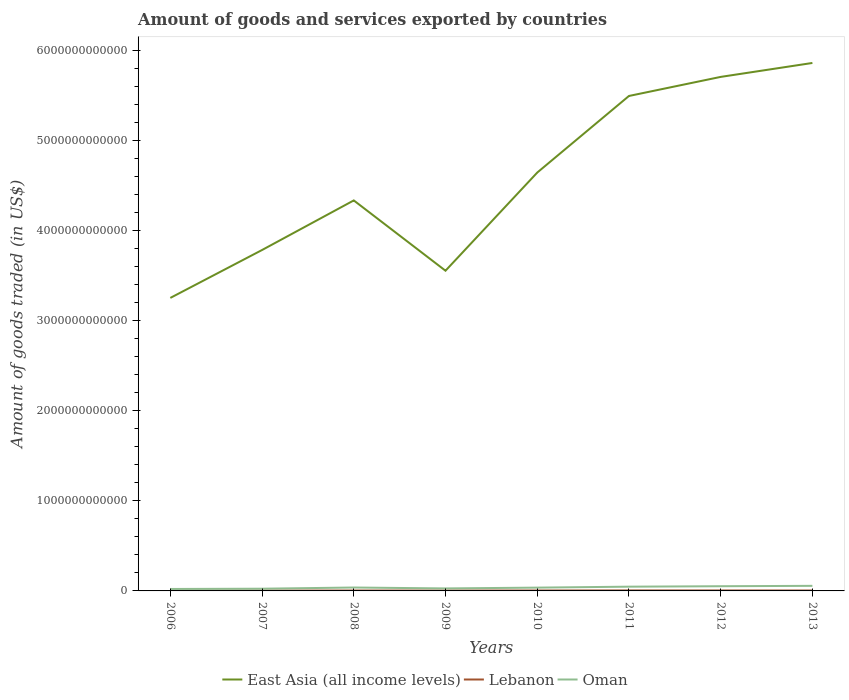How many different coloured lines are there?
Provide a succinct answer. 3. Does the line corresponding to Oman intersect with the line corresponding to Lebanon?
Keep it short and to the point. No. Across all years, what is the maximum total amount of goods and services exported in East Asia (all income levels)?
Provide a short and direct response. 3.25e+12. In which year was the total amount of goods and services exported in Oman maximum?
Provide a short and direct response. 2006. What is the total total amount of goods and services exported in Oman in the graph?
Ensure brevity in your answer.  -4.29e+09. What is the difference between the highest and the second highest total amount of goods and services exported in Oman?
Your response must be concise. 3.48e+1. What is the difference between the highest and the lowest total amount of goods and services exported in Lebanon?
Ensure brevity in your answer.  5. Is the total amount of goods and services exported in Oman strictly greater than the total amount of goods and services exported in Lebanon over the years?
Give a very brief answer. No. How many years are there in the graph?
Provide a succinct answer. 8. What is the difference between two consecutive major ticks on the Y-axis?
Provide a succinct answer. 1.00e+12. Are the values on the major ticks of Y-axis written in scientific E-notation?
Your response must be concise. No. Where does the legend appear in the graph?
Your response must be concise. Bottom center. How are the legend labels stacked?
Your response must be concise. Horizontal. What is the title of the graph?
Make the answer very short. Amount of goods and services exported by countries. Does "Bulgaria" appear as one of the legend labels in the graph?
Offer a very short reply. No. What is the label or title of the Y-axis?
Your answer should be compact. Amount of goods traded (in US$). What is the Amount of goods traded (in US$) of East Asia (all income levels) in 2006?
Make the answer very short. 3.25e+12. What is the Amount of goods traded (in US$) in Lebanon in 2006?
Give a very brief answer. 2.81e+09. What is the Amount of goods traded (in US$) of Oman in 2006?
Your response must be concise. 2.16e+1. What is the Amount of goods traded (in US$) in East Asia (all income levels) in 2007?
Keep it short and to the point. 3.78e+12. What is the Amount of goods traded (in US$) of Lebanon in 2007?
Give a very brief answer. 3.57e+09. What is the Amount of goods traded (in US$) of Oman in 2007?
Offer a very short reply. 2.47e+1. What is the Amount of goods traded (in US$) in East Asia (all income levels) in 2008?
Offer a terse response. 4.33e+12. What is the Amount of goods traded (in US$) in Lebanon in 2008?
Make the answer very short. 4.45e+09. What is the Amount of goods traded (in US$) of Oman in 2008?
Offer a very short reply. 3.77e+1. What is the Amount of goods traded (in US$) in East Asia (all income levels) in 2009?
Ensure brevity in your answer.  3.55e+12. What is the Amount of goods traded (in US$) of Lebanon in 2009?
Your answer should be very brief. 4.19e+09. What is the Amount of goods traded (in US$) of Oman in 2009?
Your answer should be very brief. 2.77e+1. What is the Amount of goods traded (in US$) in East Asia (all income levels) in 2010?
Offer a very short reply. 4.64e+12. What is the Amount of goods traded (in US$) of Lebanon in 2010?
Your response must be concise. 4.69e+09. What is the Amount of goods traded (in US$) of Oman in 2010?
Your answer should be very brief. 3.66e+1. What is the Amount of goods traded (in US$) in East Asia (all income levels) in 2011?
Your answer should be compact. 5.49e+12. What is the Amount of goods traded (in US$) in Lebanon in 2011?
Offer a very short reply. 5.39e+09. What is the Amount of goods traded (in US$) of Oman in 2011?
Your answer should be very brief. 4.71e+1. What is the Amount of goods traded (in US$) of East Asia (all income levels) in 2012?
Make the answer very short. 5.70e+12. What is the Amount of goods traded (in US$) of Lebanon in 2012?
Provide a short and direct response. 5.01e+09. What is the Amount of goods traded (in US$) of Oman in 2012?
Provide a short and direct response. 5.21e+1. What is the Amount of goods traded (in US$) of East Asia (all income levels) in 2013?
Provide a succinct answer. 5.86e+12. What is the Amount of goods traded (in US$) in Lebanon in 2013?
Make the answer very short. 4.50e+09. What is the Amount of goods traded (in US$) of Oman in 2013?
Your response must be concise. 5.64e+1. Across all years, what is the maximum Amount of goods traded (in US$) in East Asia (all income levels)?
Give a very brief answer. 5.86e+12. Across all years, what is the maximum Amount of goods traded (in US$) of Lebanon?
Offer a very short reply. 5.39e+09. Across all years, what is the maximum Amount of goods traded (in US$) of Oman?
Keep it short and to the point. 5.64e+1. Across all years, what is the minimum Amount of goods traded (in US$) of East Asia (all income levels)?
Keep it short and to the point. 3.25e+12. Across all years, what is the minimum Amount of goods traded (in US$) in Lebanon?
Ensure brevity in your answer.  2.81e+09. Across all years, what is the minimum Amount of goods traded (in US$) of Oman?
Offer a terse response. 2.16e+1. What is the total Amount of goods traded (in US$) of East Asia (all income levels) in the graph?
Offer a very short reply. 3.66e+13. What is the total Amount of goods traded (in US$) of Lebanon in the graph?
Your response must be concise. 3.46e+1. What is the total Amount of goods traded (in US$) of Oman in the graph?
Your response must be concise. 3.04e+11. What is the difference between the Amount of goods traded (in US$) of East Asia (all income levels) in 2006 and that in 2007?
Your response must be concise. -5.32e+11. What is the difference between the Amount of goods traded (in US$) of Lebanon in 2006 and that in 2007?
Provide a short and direct response. -7.60e+08. What is the difference between the Amount of goods traded (in US$) in Oman in 2006 and that in 2007?
Ensure brevity in your answer.  -3.11e+09. What is the difference between the Amount of goods traded (in US$) in East Asia (all income levels) in 2006 and that in 2008?
Keep it short and to the point. -1.08e+12. What is the difference between the Amount of goods traded (in US$) in Lebanon in 2006 and that in 2008?
Your response must be concise. -1.64e+09. What is the difference between the Amount of goods traded (in US$) in Oman in 2006 and that in 2008?
Give a very brief answer. -1.61e+1. What is the difference between the Amount of goods traded (in US$) in East Asia (all income levels) in 2006 and that in 2009?
Give a very brief answer. -3.02e+11. What is the difference between the Amount of goods traded (in US$) of Lebanon in 2006 and that in 2009?
Your answer should be very brief. -1.37e+09. What is the difference between the Amount of goods traded (in US$) of Oman in 2006 and that in 2009?
Make the answer very short. -6.07e+09. What is the difference between the Amount of goods traded (in US$) in East Asia (all income levels) in 2006 and that in 2010?
Give a very brief answer. -1.39e+12. What is the difference between the Amount of goods traded (in US$) in Lebanon in 2006 and that in 2010?
Keep it short and to the point. -1.87e+09. What is the difference between the Amount of goods traded (in US$) of Oman in 2006 and that in 2010?
Your answer should be very brief. -1.50e+1. What is the difference between the Amount of goods traded (in US$) of East Asia (all income levels) in 2006 and that in 2011?
Provide a short and direct response. -2.24e+12. What is the difference between the Amount of goods traded (in US$) of Lebanon in 2006 and that in 2011?
Offer a very short reply. -2.57e+09. What is the difference between the Amount of goods traded (in US$) in Oman in 2006 and that in 2011?
Ensure brevity in your answer.  -2.55e+1. What is the difference between the Amount of goods traded (in US$) of East Asia (all income levels) in 2006 and that in 2012?
Make the answer very short. -2.45e+12. What is the difference between the Amount of goods traded (in US$) of Lebanon in 2006 and that in 2012?
Keep it short and to the point. -2.19e+09. What is the difference between the Amount of goods traded (in US$) of Oman in 2006 and that in 2012?
Your answer should be compact. -3.06e+1. What is the difference between the Amount of goods traded (in US$) in East Asia (all income levels) in 2006 and that in 2013?
Make the answer very short. -2.61e+12. What is the difference between the Amount of goods traded (in US$) in Lebanon in 2006 and that in 2013?
Your answer should be very brief. -1.68e+09. What is the difference between the Amount of goods traded (in US$) in Oman in 2006 and that in 2013?
Provide a succinct answer. -3.48e+1. What is the difference between the Amount of goods traded (in US$) of East Asia (all income levels) in 2007 and that in 2008?
Give a very brief answer. -5.50e+11. What is the difference between the Amount of goods traded (in US$) of Lebanon in 2007 and that in 2008?
Offer a very short reply. -8.79e+08. What is the difference between the Amount of goods traded (in US$) in Oman in 2007 and that in 2008?
Give a very brief answer. -1.30e+1. What is the difference between the Amount of goods traded (in US$) of East Asia (all income levels) in 2007 and that in 2009?
Offer a very short reply. 2.30e+11. What is the difference between the Amount of goods traded (in US$) in Lebanon in 2007 and that in 2009?
Keep it short and to the point. -6.13e+08. What is the difference between the Amount of goods traded (in US$) in Oman in 2007 and that in 2009?
Your answer should be compact. -2.96e+09. What is the difference between the Amount of goods traded (in US$) in East Asia (all income levels) in 2007 and that in 2010?
Offer a very short reply. -8.59e+11. What is the difference between the Amount of goods traded (in US$) in Lebanon in 2007 and that in 2010?
Provide a succinct answer. -1.11e+09. What is the difference between the Amount of goods traded (in US$) of Oman in 2007 and that in 2010?
Ensure brevity in your answer.  -1.19e+1. What is the difference between the Amount of goods traded (in US$) of East Asia (all income levels) in 2007 and that in 2011?
Provide a short and direct response. -1.71e+12. What is the difference between the Amount of goods traded (in US$) of Lebanon in 2007 and that in 2011?
Make the answer very short. -1.81e+09. What is the difference between the Amount of goods traded (in US$) in Oman in 2007 and that in 2011?
Make the answer very short. -2.24e+1. What is the difference between the Amount of goods traded (in US$) of East Asia (all income levels) in 2007 and that in 2012?
Make the answer very short. -1.92e+12. What is the difference between the Amount of goods traded (in US$) of Lebanon in 2007 and that in 2012?
Provide a short and direct response. -1.43e+09. What is the difference between the Amount of goods traded (in US$) of Oman in 2007 and that in 2012?
Provide a succinct answer. -2.74e+1. What is the difference between the Amount of goods traded (in US$) in East Asia (all income levels) in 2007 and that in 2013?
Your answer should be compact. -2.08e+12. What is the difference between the Amount of goods traded (in US$) of Lebanon in 2007 and that in 2013?
Keep it short and to the point. -9.24e+08. What is the difference between the Amount of goods traded (in US$) of Oman in 2007 and that in 2013?
Keep it short and to the point. -3.17e+1. What is the difference between the Amount of goods traded (in US$) in East Asia (all income levels) in 2008 and that in 2009?
Your answer should be compact. 7.80e+11. What is the difference between the Amount of goods traded (in US$) in Lebanon in 2008 and that in 2009?
Offer a very short reply. 2.67e+08. What is the difference between the Amount of goods traded (in US$) of Oman in 2008 and that in 2009?
Your response must be concise. 1.01e+1. What is the difference between the Amount of goods traded (in US$) in East Asia (all income levels) in 2008 and that in 2010?
Make the answer very short. -3.09e+11. What is the difference between the Amount of goods traded (in US$) of Lebanon in 2008 and that in 2010?
Your answer should be very brief. -2.35e+08. What is the difference between the Amount of goods traded (in US$) of Oman in 2008 and that in 2010?
Provide a short and direct response. 1.12e+09. What is the difference between the Amount of goods traded (in US$) of East Asia (all income levels) in 2008 and that in 2011?
Give a very brief answer. -1.16e+12. What is the difference between the Amount of goods traded (in US$) of Lebanon in 2008 and that in 2011?
Your answer should be compact. -9.32e+08. What is the difference between the Amount of goods traded (in US$) in Oman in 2008 and that in 2011?
Give a very brief answer. -9.37e+09. What is the difference between the Amount of goods traded (in US$) in East Asia (all income levels) in 2008 and that in 2012?
Provide a short and direct response. -1.37e+12. What is the difference between the Amount of goods traded (in US$) in Lebanon in 2008 and that in 2012?
Keep it short and to the point. -5.55e+08. What is the difference between the Amount of goods traded (in US$) of Oman in 2008 and that in 2012?
Provide a short and direct response. -1.44e+1. What is the difference between the Amount of goods traded (in US$) of East Asia (all income levels) in 2008 and that in 2013?
Offer a very short reply. -1.53e+12. What is the difference between the Amount of goods traded (in US$) in Lebanon in 2008 and that in 2013?
Ensure brevity in your answer.  -4.51e+07. What is the difference between the Amount of goods traded (in US$) of Oman in 2008 and that in 2013?
Provide a short and direct response. -1.87e+1. What is the difference between the Amount of goods traded (in US$) in East Asia (all income levels) in 2009 and that in 2010?
Make the answer very short. -1.09e+12. What is the difference between the Amount of goods traded (in US$) in Lebanon in 2009 and that in 2010?
Provide a succinct answer. -5.02e+08. What is the difference between the Amount of goods traded (in US$) of Oman in 2009 and that in 2010?
Offer a terse response. -8.95e+09. What is the difference between the Amount of goods traded (in US$) of East Asia (all income levels) in 2009 and that in 2011?
Your answer should be compact. -1.94e+12. What is the difference between the Amount of goods traded (in US$) in Lebanon in 2009 and that in 2011?
Offer a terse response. -1.20e+09. What is the difference between the Amount of goods traded (in US$) in Oman in 2009 and that in 2011?
Your response must be concise. -1.94e+1. What is the difference between the Amount of goods traded (in US$) of East Asia (all income levels) in 2009 and that in 2012?
Make the answer very short. -2.15e+12. What is the difference between the Amount of goods traded (in US$) of Lebanon in 2009 and that in 2012?
Make the answer very short. -8.21e+08. What is the difference between the Amount of goods traded (in US$) in Oman in 2009 and that in 2012?
Your answer should be very brief. -2.45e+1. What is the difference between the Amount of goods traded (in US$) in East Asia (all income levels) in 2009 and that in 2013?
Provide a succinct answer. -2.31e+12. What is the difference between the Amount of goods traded (in US$) of Lebanon in 2009 and that in 2013?
Offer a very short reply. -3.12e+08. What is the difference between the Amount of goods traded (in US$) in Oman in 2009 and that in 2013?
Ensure brevity in your answer.  -2.88e+1. What is the difference between the Amount of goods traded (in US$) in East Asia (all income levels) in 2010 and that in 2011?
Your answer should be very brief. -8.50e+11. What is the difference between the Amount of goods traded (in US$) of Lebanon in 2010 and that in 2011?
Keep it short and to the point. -6.97e+08. What is the difference between the Amount of goods traded (in US$) in Oman in 2010 and that in 2011?
Offer a terse response. -1.05e+1. What is the difference between the Amount of goods traded (in US$) in East Asia (all income levels) in 2010 and that in 2012?
Your response must be concise. -1.06e+12. What is the difference between the Amount of goods traded (in US$) in Lebanon in 2010 and that in 2012?
Your answer should be very brief. -3.20e+08. What is the difference between the Amount of goods traded (in US$) of Oman in 2010 and that in 2012?
Your response must be concise. -1.55e+1. What is the difference between the Amount of goods traded (in US$) in East Asia (all income levels) in 2010 and that in 2013?
Ensure brevity in your answer.  -1.22e+12. What is the difference between the Amount of goods traded (in US$) of Lebanon in 2010 and that in 2013?
Your response must be concise. 1.90e+08. What is the difference between the Amount of goods traded (in US$) of Oman in 2010 and that in 2013?
Give a very brief answer. -1.98e+1. What is the difference between the Amount of goods traded (in US$) of East Asia (all income levels) in 2011 and that in 2012?
Provide a short and direct response. -2.12e+11. What is the difference between the Amount of goods traded (in US$) of Lebanon in 2011 and that in 2012?
Offer a very short reply. 3.77e+08. What is the difference between the Amount of goods traded (in US$) in Oman in 2011 and that in 2012?
Your answer should be very brief. -5.05e+09. What is the difference between the Amount of goods traded (in US$) in East Asia (all income levels) in 2011 and that in 2013?
Make the answer very short. -3.66e+11. What is the difference between the Amount of goods traded (in US$) of Lebanon in 2011 and that in 2013?
Offer a very short reply. 8.87e+08. What is the difference between the Amount of goods traded (in US$) of Oman in 2011 and that in 2013?
Your answer should be compact. -9.34e+09. What is the difference between the Amount of goods traded (in US$) of East Asia (all income levels) in 2012 and that in 2013?
Your answer should be very brief. -1.55e+11. What is the difference between the Amount of goods traded (in US$) in Lebanon in 2012 and that in 2013?
Offer a terse response. 5.10e+08. What is the difference between the Amount of goods traded (in US$) in Oman in 2012 and that in 2013?
Provide a short and direct response. -4.29e+09. What is the difference between the Amount of goods traded (in US$) of East Asia (all income levels) in 2006 and the Amount of goods traded (in US$) of Lebanon in 2007?
Make the answer very short. 3.25e+12. What is the difference between the Amount of goods traded (in US$) of East Asia (all income levels) in 2006 and the Amount of goods traded (in US$) of Oman in 2007?
Provide a succinct answer. 3.23e+12. What is the difference between the Amount of goods traded (in US$) in Lebanon in 2006 and the Amount of goods traded (in US$) in Oman in 2007?
Offer a terse response. -2.19e+1. What is the difference between the Amount of goods traded (in US$) in East Asia (all income levels) in 2006 and the Amount of goods traded (in US$) in Lebanon in 2008?
Provide a succinct answer. 3.25e+12. What is the difference between the Amount of goods traded (in US$) of East Asia (all income levels) in 2006 and the Amount of goods traded (in US$) of Oman in 2008?
Make the answer very short. 3.21e+12. What is the difference between the Amount of goods traded (in US$) in Lebanon in 2006 and the Amount of goods traded (in US$) in Oman in 2008?
Offer a very short reply. -3.49e+1. What is the difference between the Amount of goods traded (in US$) in East Asia (all income levels) in 2006 and the Amount of goods traded (in US$) in Lebanon in 2009?
Make the answer very short. 3.25e+12. What is the difference between the Amount of goods traded (in US$) of East Asia (all income levels) in 2006 and the Amount of goods traded (in US$) of Oman in 2009?
Give a very brief answer. 3.22e+12. What is the difference between the Amount of goods traded (in US$) in Lebanon in 2006 and the Amount of goods traded (in US$) in Oman in 2009?
Your answer should be very brief. -2.48e+1. What is the difference between the Amount of goods traded (in US$) in East Asia (all income levels) in 2006 and the Amount of goods traded (in US$) in Lebanon in 2010?
Your answer should be compact. 3.25e+12. What is the difference between the Amount of goods traded (in US$) in East Asia (all income levels) in 2006 and the Amount of goods traded (in US$) in Oman in 2010?
Provide a succinct answer. 3.22e+12. What is the difference between the Amount of goods traded (in US$) in Lebanon in 2006 and the Amount of goods traded (in US$) in Oman in 2010?
Give a very brief answer. -3.38e+1. What is the difference between the Amount of goods traded (in US$) in East Asia (all income levels) in 2006 and the Amount of goods traded (in US$) in Lebanon in 2011?
Keep it short and to the point. 3.25e+12. What is the difference between the Amount of goods traded (in US$) in East Asia (all income levels) in 2006 and the Amount of goods traded (in US$) in Oman in 2011?
Your answer should be compact. 3.20e+12. What is the difference between the Amount of goods traded (in US$) in Lebanon in 2006 and the Amount of goods traded (in US$) in Oman in 2011?
Keep it short and to the point. -4.43e+1. What is the difference between the Amount of goods traded (in US$) of East Asia (all income levels) in 2006 and the Amount of goods traded (in US$) of Lebanon in 2012?
Offer a very short reply. 3.25e+12. What is the difference between the Amount of goods traded (in US$) of East Asia (all income levels) in 2006 and the Amount of goods traded (in US$) of Oman in 2012?
Make the answer very short. 3.20e+12. What is the difference between the Amount of goods traded (in US$) in Lebanon in 2006 and the Amount of goods traded (in US$) in Oman in 2012?
Your answer should be compact. -4.93e+1. What is the difference between the Amount of goods traded (in US$) of East Asia (all income levels) in 2006 and the Amount of goods traded (in US$) of Lebanon in 2013?
Provide a short and direct response. 3.25e+12. What is the difference between the Amount of goods traded (in US$) in East Asia (all income levels) in 2006 and the Amount of goods traded (in US$) in Oman in 2013?
Ensure brevity in your answer.  3.20e+12. What is the difference between the Amount of goods traded (in US$) in Lebanon in 2006 and the Amount of goods traded (in US$) in Oman in 2013?
Your answer should be very brief. -5.36e+1. What is the difference between the Amount of goods traded (in US$) in East Asia (all income levels) in 2007 and the Amount of goods traded (in US$) in Lebanon in 2008?
Give a very brief answer. 3.78e+12. What is the difference between the Amount of goods traded (in US$) of East Asia (all income levels) in 2007 and the Amount of goods traded (in US$) of Oman in 2008?
Your answer should be compact. 3.75e+12. What is the difference between the Amount of goods traded (in US$) of Lebanon in 2007 and the Amount of goods traded (in US$) of Oman in 2008?
Provide a succinct answer. -3.41e+1. What is the difference between the Amount of goods traded (in US$) of East Asia (all income levels) in 2007 and the Amount of goods traded (in US$) of Lebanon in 2009?
Make the answer very short. 3.78e+12. What is the difference between the Amount of goods traded (in US$) in East Asia (all income levels) in 2007 and the Amount of goods traded (in US$) in Oman in 2009?
Provide a succinct answer. 3.76e+12. What is the difference between the Amount of goods traded (in US$) of Lebanon in 2007 and the Amount of goods traded (in US$) of Oman in 2009?
Ensure brevity in your answer.  -2.41e+1. What is the difference between the Amount of goods traded (in US$) in East Asia (all income levels) in 2007 and the Amount of goods traded (in US$) in Lebanon in 2010?
Make the answer very short. 3.78e+12. What is the difference between the Amount of goods traded (in US$) of East Asia (all income levels) in 2007 and the Amount of goods traded (in US$) of Oman in 2010?
Make the answer very short. 3.75e+12. What is the difference between the Amount of goods traded (in US$) in Lebanon in 2007 and the Amount of goods traded (in US$) in Oman in 2010?
Your answer should be compact. -3.30e+1. What is the difference between the Amount of goods traded (in US$) in East Asia (all income levels) in 2007 and the Amount of goods traded (in US$) in Lebanon in 2011?
Ensure brevity in your answer.  3.78e+12. What is the difference between the Amount of goods traded (in US$) in East Asia (all income levels) in 2007 and the Amount of goods traded (in US$) in Oman in 2011?
Your response must be concise. 3.74e+12. What is the difference between the Amount of goods traded (in US$) in Lebanon in 2007 and the Amount of goods traded (in US$) in Oman in 2011?
Provide a succinct answer. -4.35e+1. What is the difference between the Amount of goods traded (in US$) of East Asia (all income levels) in 2007 and the Amount of goods traded (in US$) of Lebanon in 2012?
Provide a succinct answer. 3.78e+12. What is the difference between the Amount of goods traded (in US$) of East Asia (all income levels) in 2007 and the Amount of goods traded (in US$) of Oman in 2012?
Offer a terse response. 3.73e+12. What is the difference between the Amount of goods traded (in US$) in Lebanon in 2007 and the Amount of goods traded (in US$) in Oman in 2012?
Your answer should be very brief. -4.86e+1. What is the difference between the Amount of goods traded (in US$) in East Asia (all income levels) in 2007 and the Amount of goods traded (in US$) in Lebanon in 2013?
Your answer should be compact. 3.78e+12. What is the difference between the Amount of goods traded (in US$) in East Asia (all income levels) in 2007 and the Amount of goods traded (in US$) in Oman in 2013?
Make the answer very short. 3.73e+12. What is the difference between the Amount of goods traded (in US$) in Lebanon in 2007 and the Amount of goods traded (in US$) in Oman in 2013?
Keep it short and to the point. -5.29e+1. What is the difference between the Amount of goods traded (in US$) in East Asia (all income levels) in 2008 and the Amount of goods traded (in US$) in Lebanon in 2009?
Your answer should be compact. 4.33e+12. What is the difference between the Amount of goods traded (in US$) in East Asia (all income levels) in 2008 and the Amount of goods traded (in US$) in Oman in 2009?
Keep it short and to the point. 4.31e+12. What is the difference between the Amount of goods traded (in US$) in Lebanon in 2008 and the Amount of goods traded (in US$) in Oman in 2009?
Ensure brevity in your answer.  -2.32e+1. What is the difference between the Amount of goods traded (in US$) of East Asia (all income levels) in 2008 and the Amount of goods traded (in US$) of Lebanon in 2010?
Offer a terse response. 4.33e+12. What is the difference between the Amount of goods traded (in US$) of East Asia (all income levels) in 2008 and the Amount of goods traded (in US$) of Oman in 2010?
Offer a very short reply. 4.30e+12. What is the difference between the Amount of goods traded (in US$) in Lebanon in 2008 and the Amount of goods traded (in US$) in Oman in 2010?
Give a very brief answer. -3.21e+1. What is the difference between the Amount of goods traded (in US$) of East Asia (all income levels) in 2008 and the Amount of goods traded (in US$) of Lebanon in 2011?
Provide a succinct answer. 4.33e+12. What is the difference between the Amount of goods traded (in US$) of East Asia (all income levels) in 2008 and the Amount of goods traded (in US$) of Oman in 2011?
Offer a terse response. 4.29e+12. What is the difference between the Amount of goods traded (in US$) of Lebanon in 2008 and the Amount of goods traded (in US$) of Oman in 2011?
Keep it short and to the point. -4.26e+1. What is the difference between the Amount of goods traded (in US$) of East Asia (all income levels) in 2008 and the Amount of goods traded (in US$) of Lebanon in 2012?
Provide a succinct answer. 4.33e+12. What is the difference between the Amount of goods traded (in US$) of East Asia (all income levels) in 2008 and the Amount of goods traded (in US$) of Oman in 2012?
Your answer should be compact. 4.28e+12. What is the difference between the Amount of goods traded (in US$) of Lebanon in 2008 and the Amount of goods traded (in US$) of Oman in 2012?
Your answer should be very brief. -4.77e+1. What is the difference between the Amount of goods traded (in US$) in East Asia (all income levels) in 2008 and the Amount of goods traded (in US$) in Lebanon in 2013?
Make the answer very short. 4.33e+12. What is the difference between the Amount of goods traded (in US$) of East Asia (all income levels) in 2008 and the Amount of goods traded (in US$) of Oman in 2013?
Keep it short and to the point. 4.28e+12. What is the difference between the Amount of goods traded (in US$) in Lebanon in 2008 and the Amount of goods traded (in US$) in Oman in 2013?
Make the answer very short. -5.20e+1. What is the difference between the Amount of goods traded (in US$) of East Asia (all income levels) in 2009 and the Amount of goods traded (in US$) of Lebanon in 2010?
Offer a terse response. 3.55e+12. What is the difference between the Amount of goods traded (in US$) in East Asia (all income levels) in 2009 and the Amount of goods traded (in US$) in Oman in 2010?
Provide a succinct answer. 3.52e+12. What is the difference between the Amount of goods traded (in US$) in Lebanon in 2009 and the Amount of goods traded (in US$) in Oman in 2010?
Provide a succinct answer. -3.24e+1. What is the difference between the Amount of goods traded (in US$) of East Asia (all income levels) in 2009 and the Amount of goods traded (in US$) of Lebanon in 2011?
Ensure brevity in your answer.  3.55e+12. What is the difference between the Amount of goods traded (in US$) in East Asia (all income levels) in 2009 and the Amount of goods traded (in US$) in Oman in 2011?
Provide a short and direct response. 3.51e+12. What is the difference between the Amount of goods traded (in US$) of Lebanon in 2009 and the Amount of goods traded (in US$) of Oman in 2011?
Give a very brief answer. -4.29e+1. What is the difference between the Amount of goods traded (in US$) in East Asia (all income levels) in 2009 and the Amount of goods traded (in US$) in Lebanon in 2012?
Your answer should be very brief. 3.55e+12. What is the difference between the Amount of goods traded (in US$) of East Asia (all income levels) in 2009 and the Amount of goods traded (in US$) of Oman in 2012?
Keep it short and to the point. 3.50e+12. What is the difference between the Amount of goods traded (in US$) in Lebanon in 2009 and the Amount of goods traded (in US$) in Oman in 2012?
Provide a short and direct response. -4.80e+1. What is the difference between the Amount of goods traded (in US$) in East Asia (all income levels) in 2009 and the Amount of goods traded (in US$) in Lebanon in 2013?
Your answer should be compact. 3.55e+12. What is the difference between the Amount of goods traded (in US$) of East Asia (all income levels) in 2009 and the Amount of goods traded (in US$) of Oman in 2013?
Keep it short and to the point. 3.50e+12. What is the difference between the Amount of goods traded (in US$) of Lebanon in 2009 and the Amount of goods traded (in US$) of Oman in 2013?
Ensure brevity in your answer.  -5.22e+1. What is the difference between the Amount of goods traded (in US$) in East Asia (all income levels) in 2010 and the Amount of goods traded (in US$) in Lebanon in 2011?
Your answer should be very brief. 4.64e+12. What is the difference between the Amount of goods traded (in US$) of East Asia (all income levels) in 2010 and the Amount of goods traded (in US$) of Oman in 2011?
Your response must be concise. 4.60e+12. What is the difference between the Amount of goods traded (in US$) in Lebanon in 2010 and the Amount of goods traded (in US$) in Oman in 2011?
Your answer should be compact. -4.24e+1. What is the difference between the Amount of goods traded (in US$) of East Asia (all income levels) in 2010 and the Amount of goods traded (in US$) of Lebanon in 2012?
Provide a succinct answer. 4.64e+12. What is the difference between the Amount of goods traded (in US$) in East Asia (all income levels) in 2010 and the Amount of goods traded (in US$) in Oman in 2012?
Your answer should be very brief. 4.59e+12. What is the difference between the Amount of goods traded (in US$) in Lebanon in 2010 and the Amount of goods traded (in US$) in Oman in 2012?
Provide a short and direct response. -4.74e+1. What is the difference between the Amount of goods traded (in US$) in East Asia (all income levels) in 2010 and the Amount of goods traded (in US$) in Lebanon in 2013?
Offer a very short reply. 4.64e+12. What is the difference between the Amount of goods traded (in US$) of East Asia (all income levels) in 2010 and the Amount of goods traded (in US$) of Oman in 2013?
Provide a succinct answer. 4.59e+12. What is the difference between the Amount of goods traded (in US$) in Lebanon in 2010 and the Amount of goods traded (in US$) in Oman in 2013?
Offer a very short reply. -5.17e+1. What is the difference between the Amount of goods traded (in US$) in East Asia (all income levels) in 2011 and the Amount of goods traded (in US$) in Lebanon in 2012?
Your answer should be compact. 5.49e+12. What is the difference between the Amount of goods traded (in US$) of East Asia (all income levels) in 2011 and the Amount of goods traded (in US$) of Oman in 2012?
Offer a very short reply. 5.44e+12. What is the difference between the Amount of goods traded (in US$) in Lebanon in 2011 and the Amount of goods traded (in US$) in Oman in 2012?
Offer a terse response. -4.68e+1. What is the difference between the Amount of goods traded (in US$) of East Asia (all income levels) in 2011 and the Amount of goods traded (in US$) of Lebanon in 2013?
Give a very brief answer. 5.49e+12. What is the difference between the Amount of goods traded (in US$) in East Asia (all income levels) in 2011 and the Amount of goods traded (in US$) in Oman in 2013?
Give a very brief answer. 5.44e+12. What is the difference between the Amount of goods traded (in US$) in Lebanon in 2011 and the Amount of goods traded (in US$) in Oman in 2013?
Offer a very short reply. -5.10e+1. What is the difference between the Amount of goods traded (in US$) of East Asia (all income levels) in 2012 and the Amount of goods traded (in US$) of Lebanon in 2013?
Your answer should be compact. 5.70e+12. What is the difference between the Amount of goods traded (in US$) in East Asia (all income levels) in 2012 and the Amount of goods traded (in US$) in Oman in 2013?
Provide a short and direct response. 5.65e+12. What is the difference between the Amount of goods traded (in US$) of Lebanon in 2012 and the Amount of goods traded (in US$) of Oman in 2013?
Provide a short and direct response. -5.14e+1. What is the average Amount of goods traded (in US$) of East Asia (all income levels) per year?
Your answer should be very brief. 4.58e+12. What is the average Amount of goods traded (in US$) in Lebanon per year?
Your answer should be compact. 4.33e+09. What is the average Amount of goods traded (in US$) of Oman per year?
Keep it short and to the point. 3.80e+1. In the year 2006, what is the difference between the Amount of goods traded (in US$) of East Asia (all income levels) and Amount of goods traded (in US$) of Lebanon?
Ensure brevity in your answer.  3.25e+12. In the year 2006, what is the difference between the Amount of goods traded (in US$) in East Asia (all income levels) and Amount of goods traded (in US$) in Oman?
Your answer should be compact. 3.23e+12. In the year 2006, what is the difference between the Amount of goods traded (in US$) of Lebanon and Amount of goods traded (in US$) of Oman?
Give a very brief answer. -1.88e+1. In the year 2007, what is the difference between the Amount of goods traded (in US$) in East Asia (all income levels) and Amount of goods traded (in US$) in Lebanon?
Provide a short and direct response. 3.78e+12. In the year 2007, what is the difference between the Amount of goods traded (in US$) in East Asia (all income levels) and Amount of goods traded (in US$) in Oman?
Make the answer very short. 3.76e+12. In the year 2007, what is the difference between the Amount of goods traded (in US$) of Lebanon and Amount of goods traded (in US$) of Oman?
Offer a very short reply. -2.11e+1. In the year 2008, what is the difference between the Amount of goods traded (in US$) of East Asia (all income levels) and Amount of goods traded (in US$) of Lebanon?
Your response must be concise. 4.33e+12. In the year 2008, what is the difference between the Amount of goods traded (in US$) in East Asia (all income levels) and Amount of goods traded (in US$) in Oman?
Your response must be concise. 4.30e+12. In the year 2008, what is the difference between the Amount of goods traded (in US$) of Lebanon and Amount of goods traded (in US$) of Oman?
Your answer should be very brief. -3.33e+1. In the year 2009, what is the difference between the Amount of goods traded (in US$) of East Asia (all income levels) and Amount of goods traded (in US$) of Lebanon?
Make the answer very short. 3.55e+12. In the year 2009, what is the difference between the Amount of goods traded (in US$) in East Asia (all income levels) and Amount of goods traded (in US$) in Oman?
Your answer should be very brief. 3.53e+12. In the year 2009, what is the difference between the Amount of goods traded (in US$) in Lebanon and Amount of goods traded (in US$) in Oman?
Your response must be concise. -2.35e+1. In the year 2010, what is the difference between the Amount of goods traded (in US$) in East Asia (all income levels) and Amount of goods traded (in US$) in Lebanon?
Make the answer very short. 4.64e+12. In the year 2010, what is the difference between the Amount of goods traded (in US$) in East Asia (all income levels) and Amount of goods traded (in US$) in Oman?
Your answer should be compact. 4.61e+12. In the year 2010, what is the difference between the Amount of goods traded (in US$) of Lebanon and Amount of goods traded (in US$) of Oman?
Offer a terse response. -3.19e+1. In the year 2011, what is the difference between the Amount of goods traded (in US$) of East Asia (all income levels) and Amount of goods traded (in US$) of Lebanon?
Your answer should be very brief. 5.49e+12. In the year 2011, what is the difference between the Amount of goods traded (in US$) of East Asia (all income levels) and Amount of goods traded (in US$) of Oman?
Your response must be concise. 5.45e+12. In the year 2011, what is the difference between the Amount of goods traded (in US$) in Lebanon and Amount of goods traded (in US$) in Oman?
Provide a short and direct response. -4.17e+1. In the year 2012, what is the difference between the Amount of goods traded (in US$) in East Asia (all income levels) and Amount of goods traded (in US$) in Lebanon?
Offer a terse response. 5.70e+12. In the year 2012, what is the difference between the Amount of goods traded (in US$) in East Asia (all income levels) and Amount of goods traded (in US$) in Oman?
Provide a short and direct response. 5.65e+12. In the year 2012, what is the difference between the Amount of goods traded (in US$) in Lebanon and Amount of goods traded (in US$) in Oman?
Your answer should be very brief. -4.71e+1. In the year 2013, what is the difference between the Amount of goods traded (in US$) in East Asia (all income levels) and Amount of goods traded (in US$) in Lebanon?
Give a very brief answer. 5.85e+12. In the year 2013, what is the difference between the Amount of goods traded (in US$) of East Asia (all income levels) and Amount of goods traded (in US$) of Oman?
Provide a succinct answer. 5.80e+12. In the year 2013, what is the difference between the Amount of goods traded (in US$) in Lebanon and Amount of goods traded (in US$) in Oman?
Give a very brief answer. -5.19e+1. What is the ratio of the Amount of goods traded (in US$) of East Asia (all income levels) in 2006 to that in 2007?
Your answer should be very brief. 0.86. What is the ratio of the Amount of goods traded (in US$) in Lebanon in 2006 to that in 2007?
Make the answer very short. 0.79. What is the ratio of the Amount of goods traded (in US$) of Oman in 2006 to that in 2007?
Provide a succinct answer. 0.87. What is the ratio of the Amount of goods traded (in US$) of East Asia (all income levels) in 2006 to that in 2008?
Keep it short and to the point. 0.75. What is the ratio of the Amount of goods traded (in US$) of Lebanon in 2006 to that in 2008?
Your answer should be very brief. 0.63. What is the ratio of the Amount of goods traded (in US$) of Oman in 2006 to that in 2008?
Provide a short and direct response. 0.57. What is the ratio of the Amount of goods traded (in US$) in East Asia (all income levels) in 2006 to that in 2009?
Offer a very short reply. 0.92. What is the ratio of the Amount of goods traded (in US$) in Lebanon in 2006 to that in 2009?
Your answer should be compact. 0.67. What is the ratio of the Amount of goods traded (in US$) of Oman in 2006 to that in 2009?
Provide a succinct answer. 0.78. What is the ratio of the Amount of goods traded (in US$) in East Asia (all income levels) in 2006 to that in 2010?
Offer a terse response. 0.7. What is the ratio of the Amount of goods traded (in US$) in Lebanon in 2006 to that in 2010?
Your answer should be very brief. 0.6. What is the ratio of the Amount of goods traded (in US$) in Oman in 2006 to that in 2010?
Your answer should be compact. 0.59. What is the ratio of the Amount of goods traded (in US$) in East Asia (all income levels) in 2006 to that in 2011?
Make the answer very short. 0.59. What is the ratio of the Amount of goods traded (in US$) of Lebanon in 2006 to that in 2011?
Your answer should be very brief. 0.52. What is the ratio of the Amount of goods traded (in US$) of Oman in 2006 to that in 2011?
Make the answer very short. 0.46. What is the ratio of the Amount of goods traded (in US$) in East Asia (all income levels) in 2006 to that in 2012?
Offer a terse response. 0.57. What is the ratio of the Amount of goods traded (in US$) of Lebanon in 2006 to that in 2012?
Give a very brief answer. 0.56. What is the ratio of the Amount of goods traded (in US$) of Oman in 2006 to that in 2012?
Ensure brevity in your answer.  0.41. What is the ratio of the Amount of goods traded (in US$) in East Asia (all income levels) in 2006 to that in 2013?
Make the answer very short. 0.56. What is the ratio of the Amount of goods traded (in US$) of Lebanon in 2006 to that in 2013?
Offer a very short reply. 0.63. What is the ratio of the Amount of goods traded (in US$) of Oman in 2006 to that in 2013?
Give a very brief answer. 0.38. What is the ratio of the Amount of goods traded (in US$) in East Asia (all income levels) in 2007 to that in 2008?
Your response must be concise. 0.87. What is the ratio of the Amount of goods traded (in US$) of Lebanon in 2007 to that in 2008?
Keep it short and to the point. 0.8. What is the ratio of the Amount of goods traded (in US$) of Oman in 2007 to that in 2008?
Offer a terse response. 0.65. What is the ratio of the Amount of goods traded (in US$) of East Asia (all income levels) in 2007 to that in 2009?
Give a very brief answer. 1.06. What is the ratio of the Amount of goods traded (in US$) in Lebanon in 2007 to that in 2009?
Give a very brief answer. 0.85. What is the ratio of the Amount of goods traded (in US$) of Oman in 2007 to that in 2009?
Your response must be concise. 0.89. What is the ratio of the Amount of goods traded (in US$) of East Asia (all income levels) in 2007 to that in 2010?
Provide a short and direct response. 0.81. What is the ratio of the Amount of goods traded (in US$) in Lebanon in 2007 to that in 2010?
Ensure brevity in your answer.  0.76. What is the ratio of the Amount of goods traded (in US$) of Oman in 2007 to that in 2010?
Ensure brevity in your answer.  0.67. What is the ratio of the Amount of goods traded (in US$) in East Asia (all income levels) in 2007 to that in 2011?
Keep it short and to the point. 0.69. What is the ratio of the Amount of goods traded (in US$) of Lebanon in 2007 to that in 2011?
Make the answer very short. 0.66. What is the ratio of the Amount of goods traded (in US$) of Oman in 2007 to that in 2011?
Your answer should be very brief. 0.52. What is the ratio of the Amount of goods traded (in US$) in East Asia (all income levels) in 2007 to that in 2012?
Offer a very short reply. 0.66. What is the ratio of the Amount of goods traded (in US$) in Lebanon in 2007 to that in 2012?
Make the answer very short. 0.71. What is the ratio of the Amount of goods traded (in US$) of Oman in 2007 to that in 2012?
Your answer should be compact. 0.47. What is the ratio of the Amount of goods traded (in US$) in East Asia (all income levels) in 2007 to that in 2013?
Ensure brevity in your answer.  0.65. What is the ratio of the Amount of goods traded (in US$) in Lebanon in 2007 to that in 2013?
Make the answer very short. 0.79. What is the ratio of the Amount of goods traded (in US$) of Oman in 2007 to that in 2013?
Give a very brief answer. 0.44. What is the ratio of the Amount of goods traded (in US$) in East Asia (all income levels) in 2008 to that in 2009?
Provide a short and direct response. 1.22. What is the ratio of the Amount of goods traded (in US$) of Lebanon in 2008 to that in 2009?
Make the answer very short. 1.06. What is the ratio of the Amount of goods traded (in US$) of Oman in 2008 to that in 2009?
Your response must be concise. 1.36. What is the ratio of the Amount of goods traded (in US$) in East Asia (all income levels) in 2008 to that in 2010?
Offer a very short reply. 0.93. What is the ratio of the Amount of goods traded (in US$) of Lebanon in 2008 to that in 2010?
Ensure brevity in your answer.  0.95. What is the ratio of the Amount of goods traded (in US$) in Oman in 2008 to that in 2010?
Your answer should be compact. 1.03. What is the ratio of the Amount of goods traded (in US$) of East Asia (all income levels) in 2008 to that in 2011?
Your response must be concise. 0.79. What is the ratio of the Amount of goods traded (in US$) in Lebanon in 2008 to that in 2011?
Your answer should be very brief. 0.83. What is the ratio of the Amount of goods traded (in US$) in Oman in 2008 to that in 2011?
Make the answer very short. 0.8. What is the ratio of the Amount of goods traded (in US$) of East Asia (all income levels) in 2008 to that in 2012?
Keep it short and to the point. 0.76. What is the ratio of the Amount of goods traded (in US$) in Lebanon in 2008 to that in 2012?
Your answer should be very brief. 0.89. What is the ratio of the Amount of goods traded (in US$) in Oman in 2008 to that in 2012?
Your response must be concise. 0.72. What is the ratio of the Amount of goods traded (in US$) in East Asia (all income levels) in 2008 to that in 2013?
Make the answer very short. 0.74. What is the ratio of the Amount of goods traded (in US$) in Lebanon in 2008 to that in 2013?
Offer a terse response. 0.99. What is the ratio of the Amount of goods traded (in US$) of Oman in 2008 to that in 2013?
Your response must be concise. 0.67. What is the ratio of the Amount of goods traded (in US$) of East Asia (all income levels) in 2009 to that in 2010?
Offer a terse response. 0.77. What is the ratio of the Amount of goods traded (in US$) of Lebanon in 2009 to that in 2010?
Your response must be concise. 0.89. What is the ratio of the Amount of goods traded (in US$) of Oman in 2009 to that in 2010?
Provide a succinct answer. 0.76. What is the ratio of the Amount of goods traded (in US$) in East Asia (all income levels) in 2009 to that in 2011?
Your response must be concise. 0.65. What is the ratio of the Amount of goods traded (in US$) in Lebanon in 2009 to that in 2011?
Give a very brief answer. 0.78. What is the ratio of the Amount of goods traded (in US$) in Oman in 2009 to that in 2011?
Give a very brief answer. 0.59. What is the ratio of the Amount of goods traded (in US$) of East Asia (all income levels) in 2009 to that in 2012?
Keep it short and to the point. 0.62. What is the ratio of the Amount of goods traded (in US$) in Lebanon in 2009 to that in 2012?
Ensure brevity in your answer.  0.84. What is the ratio of the Amount of goods traded (in US$) of Oman in 2009 to that in 2012?
Offer a terse response. 0.53. What is the ratio of the Amount of goods traded (in US$) in East Asia (all income levels) in 2009 to that in 2013?
Your response must be concise. 0.61. What is the ratio of the Amount of goods traded (in US$) of Lebanon in 2009 to that in 2013?
Offer a terse response. 0.93. What is the ratio of the Amount of goods traded (in US$) in Oman in 2009 to that in 2013?
Provide a short and direct response. 0.49. What is the ratio of the Amount of goods traded (in US$) in East Asia (all income levels) in 2010 to that in 2011?
Keep it short and to the point. 0.85. What is the ratio of the Amount of goods traded (in US$) of Lebanon in 2010 to that in 2011?
Your answer should be compact. 0.87. What is the ratio of the Amount of goods traded (in US$) of Oman in 2010 to that in 2011?
Ensure brevity in your answer.  0.78. What is the ratio of the Amount of goods traded (in US$) of East Asia (all income levels) in 2010 to that in 2012?
Your answer should be very brief. 0.81. What is the ratio of the Amount of goods traded (in US$) of Lebanon in 2010 to that in 2012?
Ensure brevity in your answer.  0.94. What is the ratio of the Amount of goods traded (in US$) of Oman in 2010 to that in 2012?
Offer a very short reply. 0.7. What is the ratio of the Amount of goods traded (in US$) in East Asia (all income levels) in 2010 to that in 2013?
Offer a very short reply. 0.79. What is the ratio of the Amount of goods traded (in US$) in Lebanon in 2010 to that in 2013?
Provide a short and direct response. 1.04. What is the ratio of the Amount of goods traded (in US$) in Oman in 2010 to that in 2013?
Provide a succinct answer. 0.65. What is the ratio of the Amount of goods traded (in US$) in East Asia (all income levels) in 2011 to that in 2012?
Keep it short and to the point. 0.96. What is the ratio of the Amount of goods traded (in US$) in Lebanon in 2011 to that in 2012?
Make the answer very short. 1.08. What is the ratio of the Amount of goods traded (in US$) in Oman in 2011 to that in 2012?
Your answer should be very brief. 0.9. What is the ratio of the Amount of goods traded (in US$) of East Asia (all income levels) in 2011 to that in 2013?
Your answer should be very brief. 0.94. What is the ratio of the Amount of goods traded (in US$) of Lebanon in 2011 to that in 2013?
Provide a succinct answer. 1.2. What is the ratio of the Amount of goods traded (in US$) of Oman in 2011 to that in 2013?
Provide a succinct answer. 0.83. What is the ratio of the Amount of goods traded (in US$) in East Asia (all income levels) in 2012 to that in 2013?
Your answer should be compact. 0.97. What is the ratio of the Amount of goods traded (in US$) in Lebanon in 2012 to that in 2013?
Provide a short and direct response. 1.11. What is the ratio of the Amount of goods traded (in US$) of Oman in 2012 to that in 2013?
Provide a succinct answer. 0.92. What is the difference between the highest and the second highest Amount of goods traded (in US$) in East Asia (all income levels)?
Offer a terse response. 1.55e+11. What is the difference between the highest and the second highest Amount of goods traded (in US$) in Lebanon?
Provide a short and direct response. 3.77e+08. What is the difference between the highest and the second highest Amount of goods traded (in US$) in Oman?
Your answer should be compact. 4.29e+09. What is the difference between the highest and the lowest Amount of goods traded (in US$) in East Asia (all income levels)?
Your response must be concise. 2.61e+12. What is the difference between the highest and the lowest Amount of goods traded (in US$) in Lebanon?
Keep it short and to the point. 2.57e+09. What is the difference between the highest and the lowest Amount of goods traded (in US$) of Oman?
Give a very brief answer. 3.48e+1. 